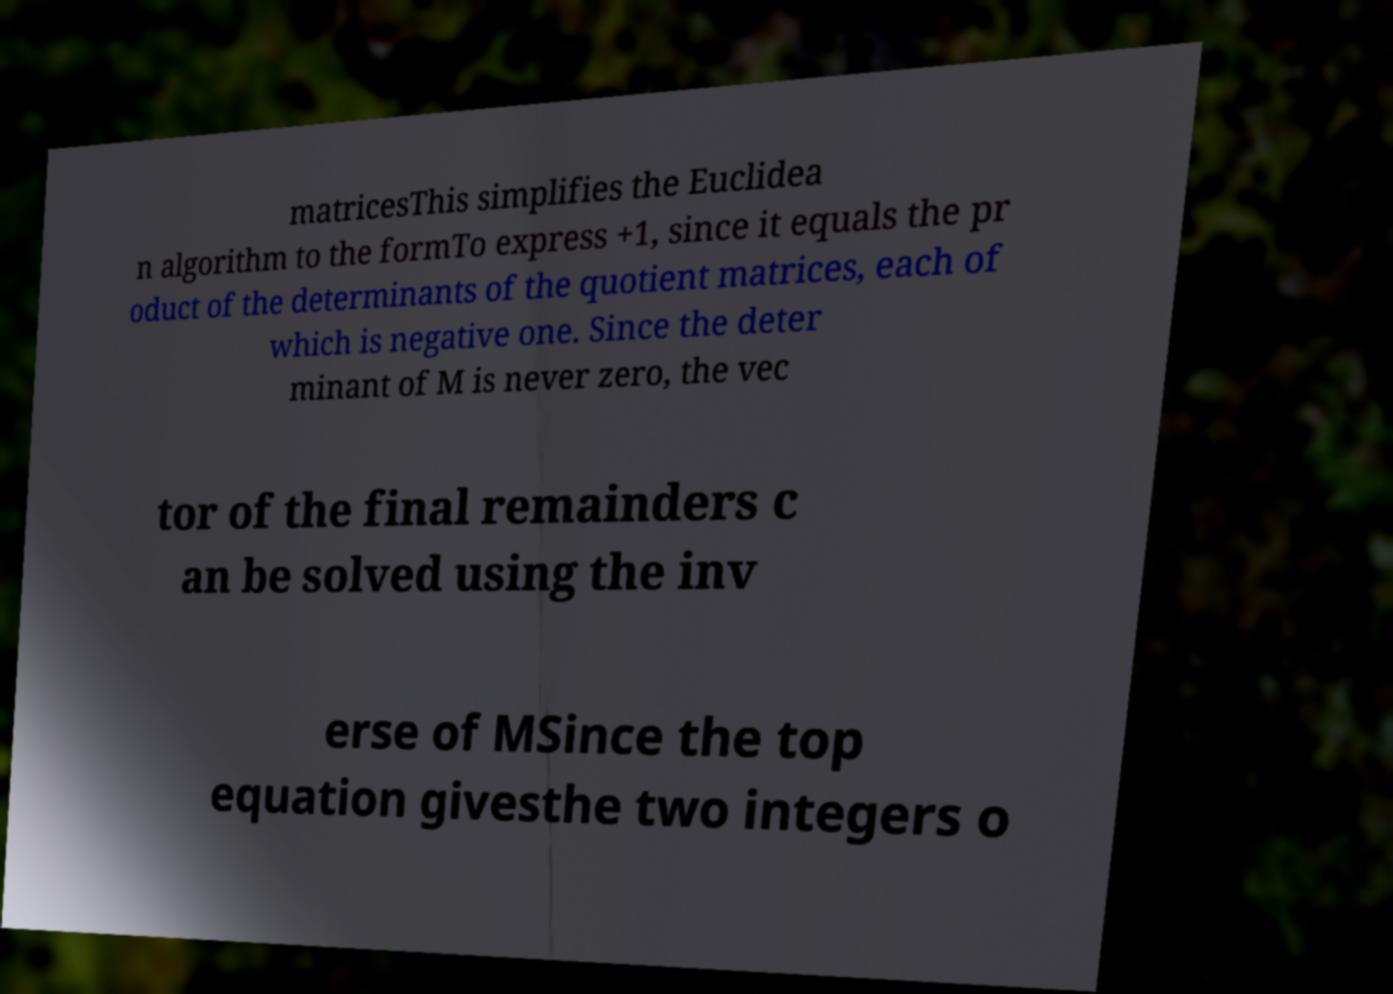Can you read and provide the text displayed in the image?This photo seems to have some interesting text. Can you extract and type it out for me? matricesThis simplifies the Euclidea n algorithm to the formTo express +1, since it equals the pr oduct of the determinants of the quotient matrices, each of which is negative one. Since the deter minant of M is never zero, the vec tor of the final remainders c an be solved using the inv erse of MSince the top equation givesthe two integers o 